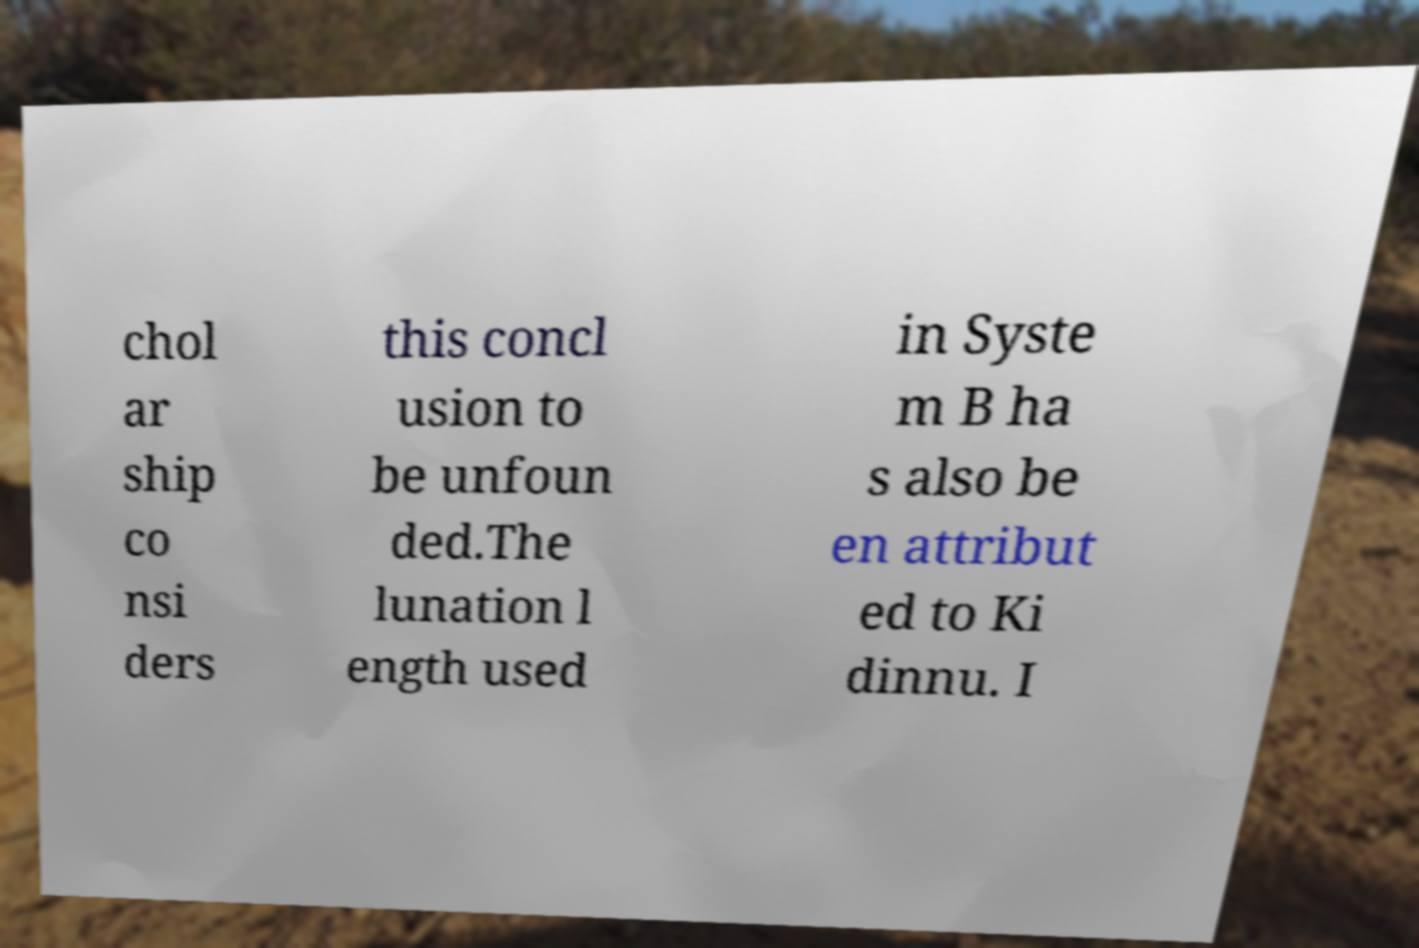Please identify and transcribe the text found in this image. chol ar ship co nsi ders this concl usion to be unfoun ded.The lunation l ength used in Syste m B ha s also be en attribut ed to Ki dinnu. I 